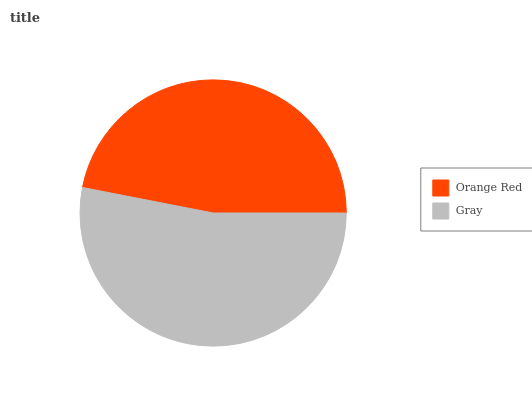Is Orange Red the minimum?
Answer yes or no. Yes. Is Gray the maximum?
Answer yes or no. Yes. Is Gray the minimum?
Answer yes or no. No. Is Gray greater than Orange Red?
Answer yes or no. Yes. Is Orange Red less than Gray?
Answer yes or no. Yes. Is Orange Red greater than Gray?
Answer yes or no. No. Is Gray less than Orange Red?
Answer yes or no. No. Is Gray the high median?
Answer yes or no. Yes. Is Orange Red the low median?
Answer yes or no. Yes. Is Orange Red the high median?
Answer yes or no. No. Is Gray the low median?
Answer yes or no. No. 